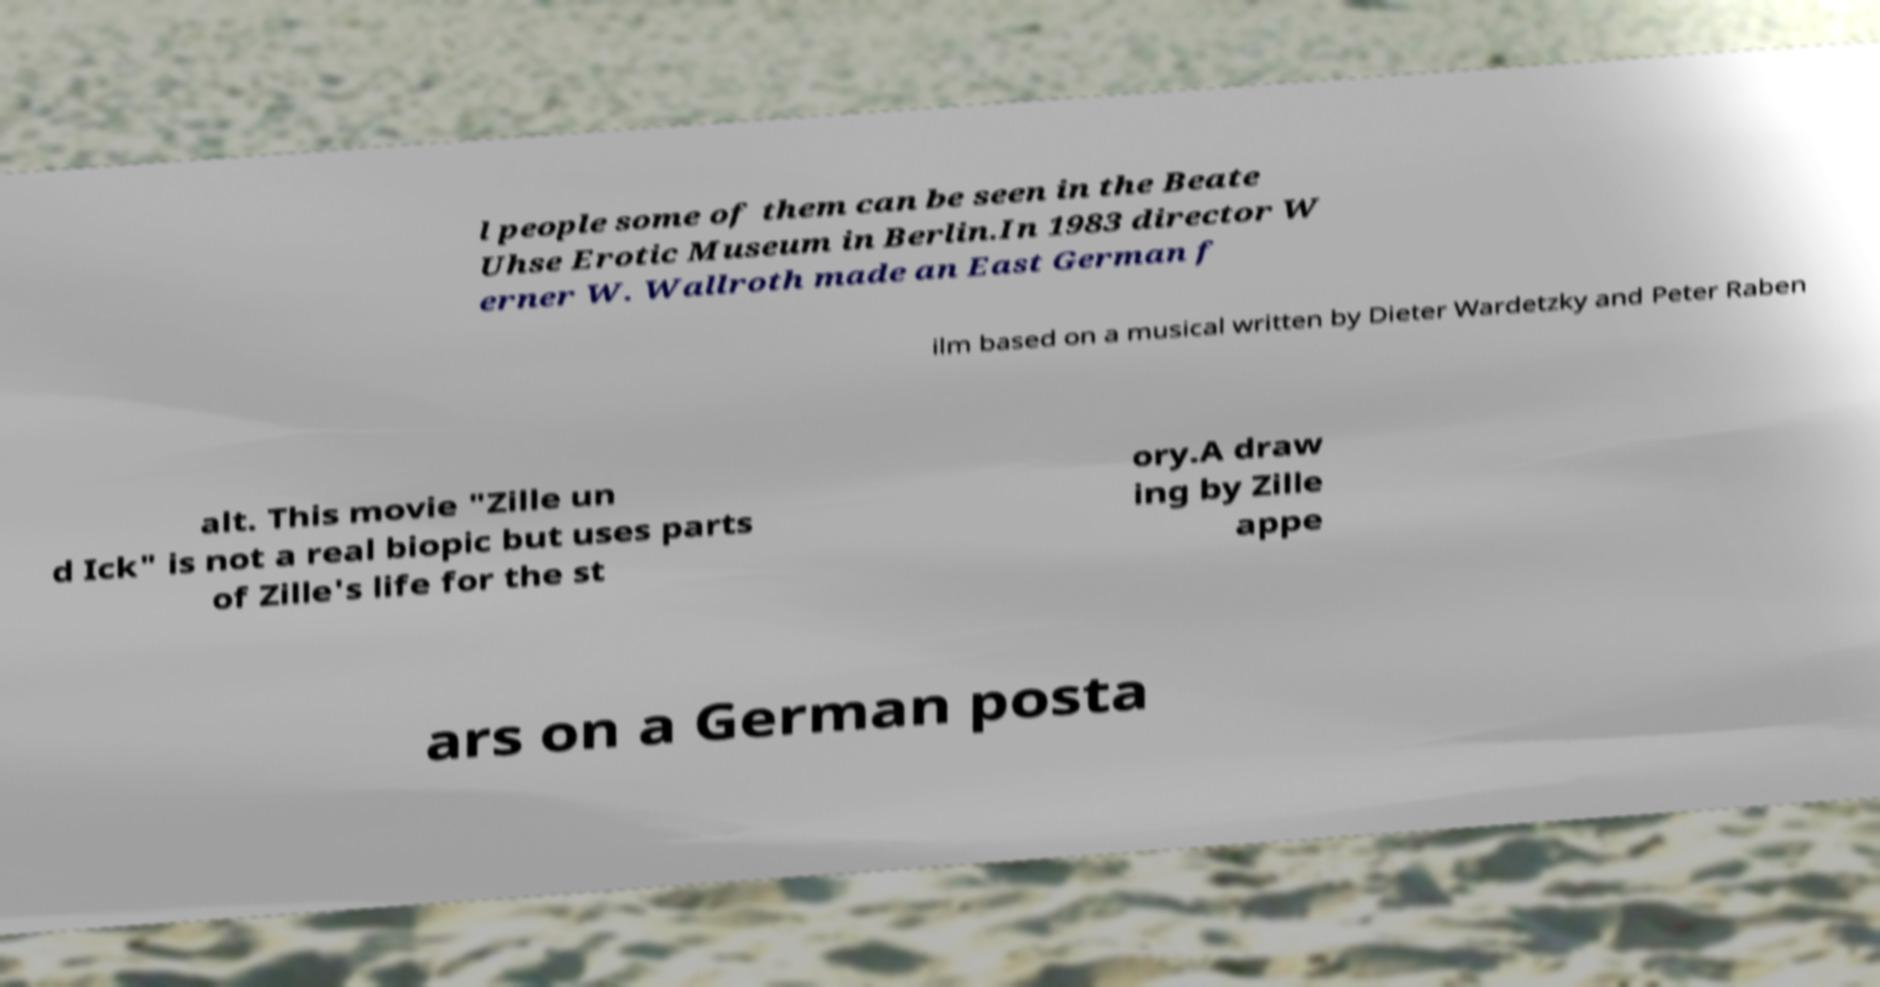For documentation purposes, I need the text within this image transcribed. Could you provide that? l people some of them can be seen in the Beate Uhse Erotic Museum in Berlin.In 1983 director W erner W. Wallroth made an East German f ilm based on a musical written by Dieter Wardetzky and Peter Raben alt. This movie "Zille un d Ick" is not a real biopic but uses parts of Zille's life for the st ory.A draw ing by Zille appe ars on a German posta 